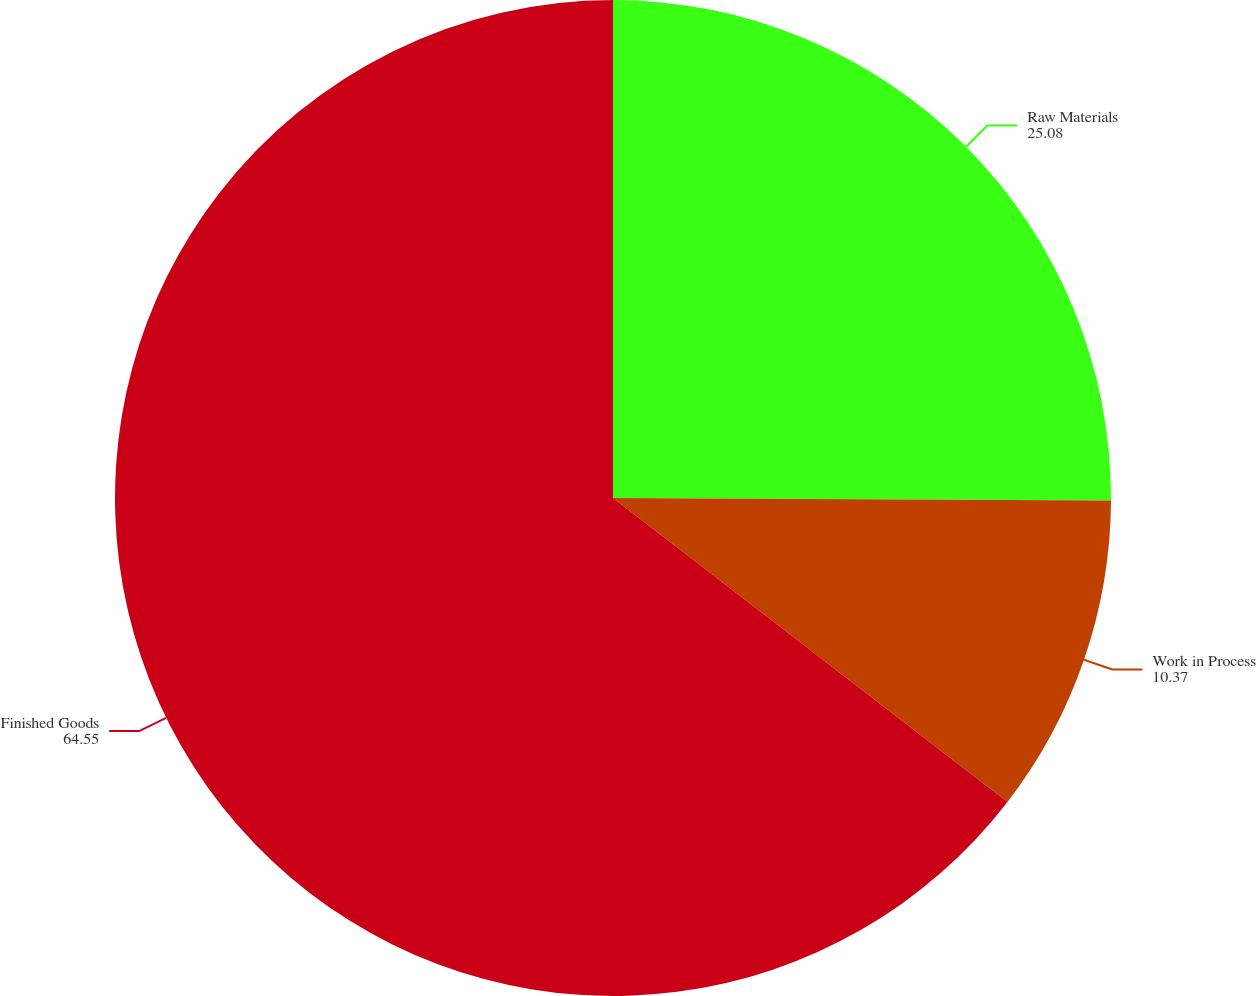Convert chart. <chart><loc_0><loc_0><loc_500><loc_500><pie_chart><fcel>Raw Materials<fcel>Work in Process<fcel>Finished Goods<nl><fcel>25.08%<fcel>10.37%<fcel>64.55%<nl></chart> 